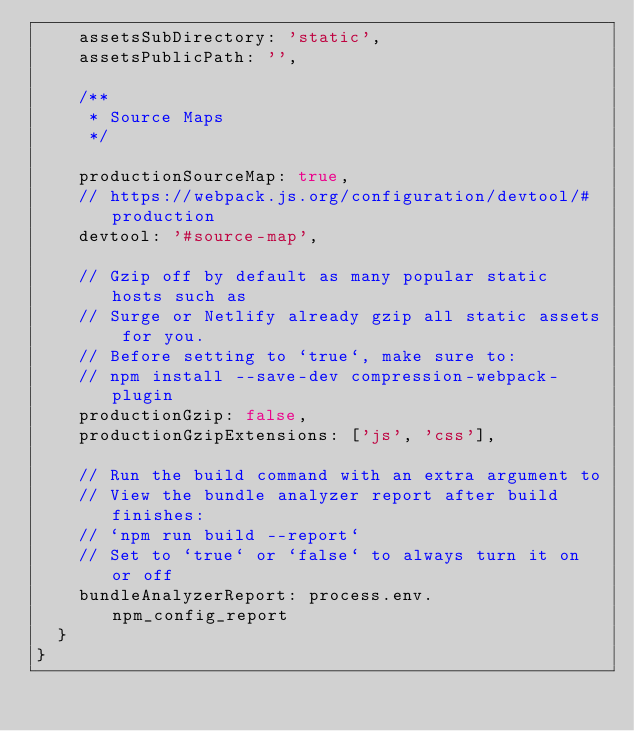<code> <loc_0><loc_0><loc_500><loc_500><_JavaScript_>    assetsSubDirectory: 'static',
    assetsPublicPath: '',

    /**
     * Source Maps
     */

    productionSourceMap: true,
    // https://webpack.js.org/configuration/devtool/#production
    devtool: '#source-map',

    // Gzip off by default as many popular static hosts such as
    // Surge or Netlify already gzip all static assets for you.
    // Before setting to `true`, make sure to:
    // npm install --save-dev compression-webpack-plugin
    productionGzip: false,
    productionGzipExtensions: ['js', 'css'],

    // Run the build command with an extra argument to
    // View the bundle analyzer report after build finishes:
    // `npm run build --report`
    // Set to `true` or `false` to always turn it on or off
    bundleAnalyzerReport: process.env.npm_config_report
  }
}
</code> 